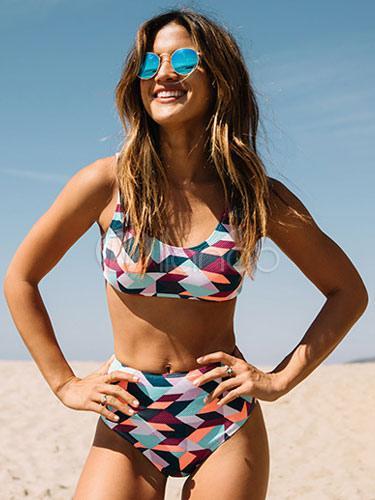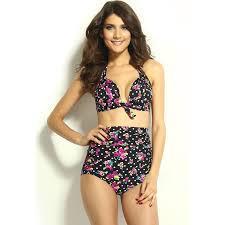The first image is the image on the left, the second image is the image on the right. Analyze the images presented: Is the assertion "All models wear bikinis with matching color tops and bottoms." valid? Answer yes or no. Yes. 